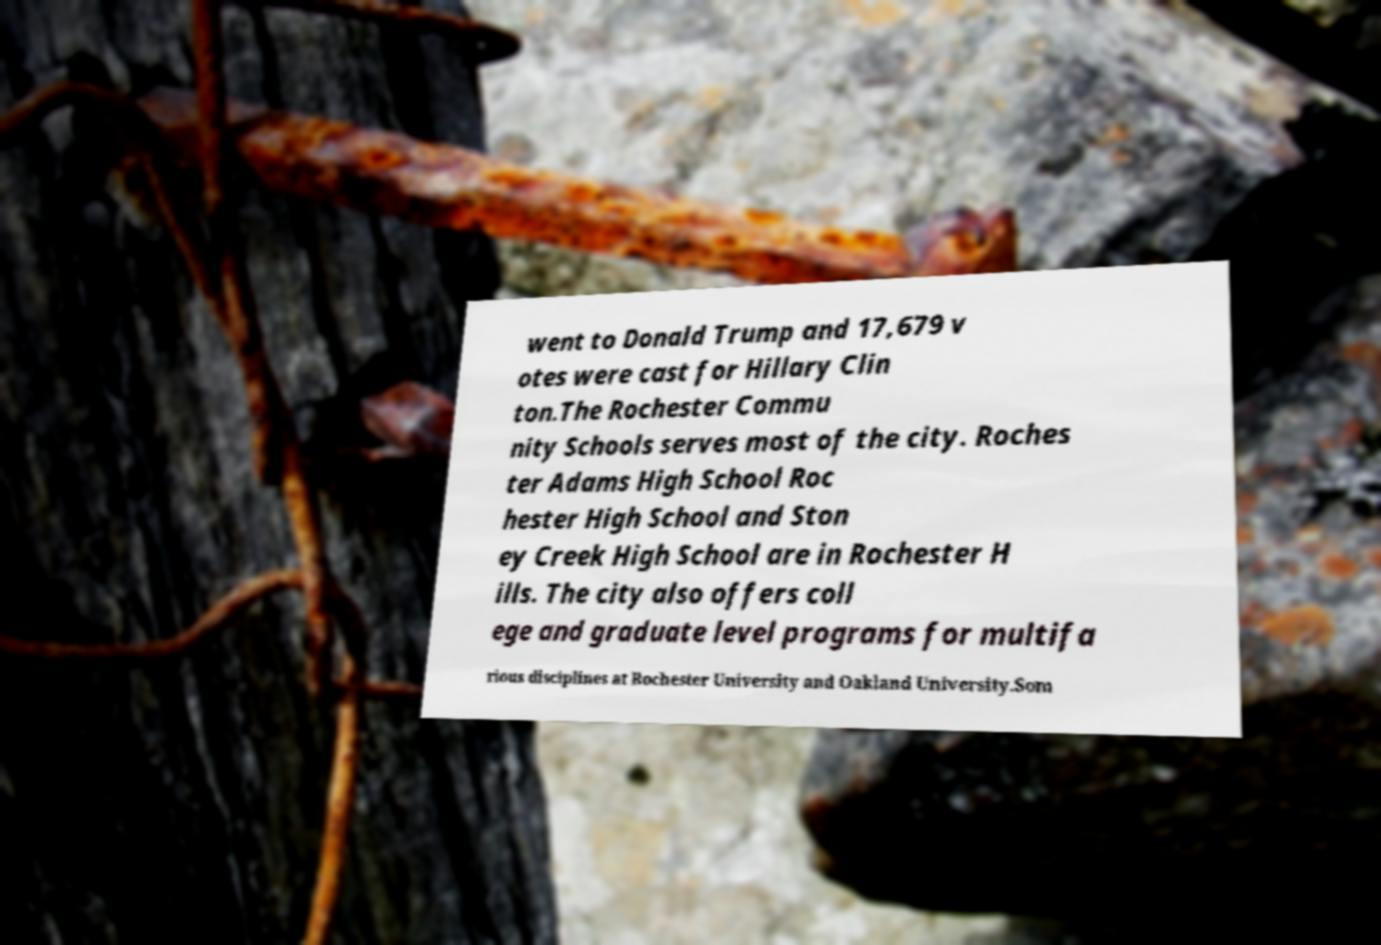Could you assist in decoding the text presented in this image and type it out clearly? went to Donald Trump and 17,679 v otes were cast for Hillary Clin ton.The Rochester Commu nity Schools serves most of the city. Roches ter Adams High School Roc hester High School and Ston ey Creek High School are in Rochester H ills. The city also offers coll ege and graduate level programs for multifa rious disciplines at Rochester University and Oakland University.Som 